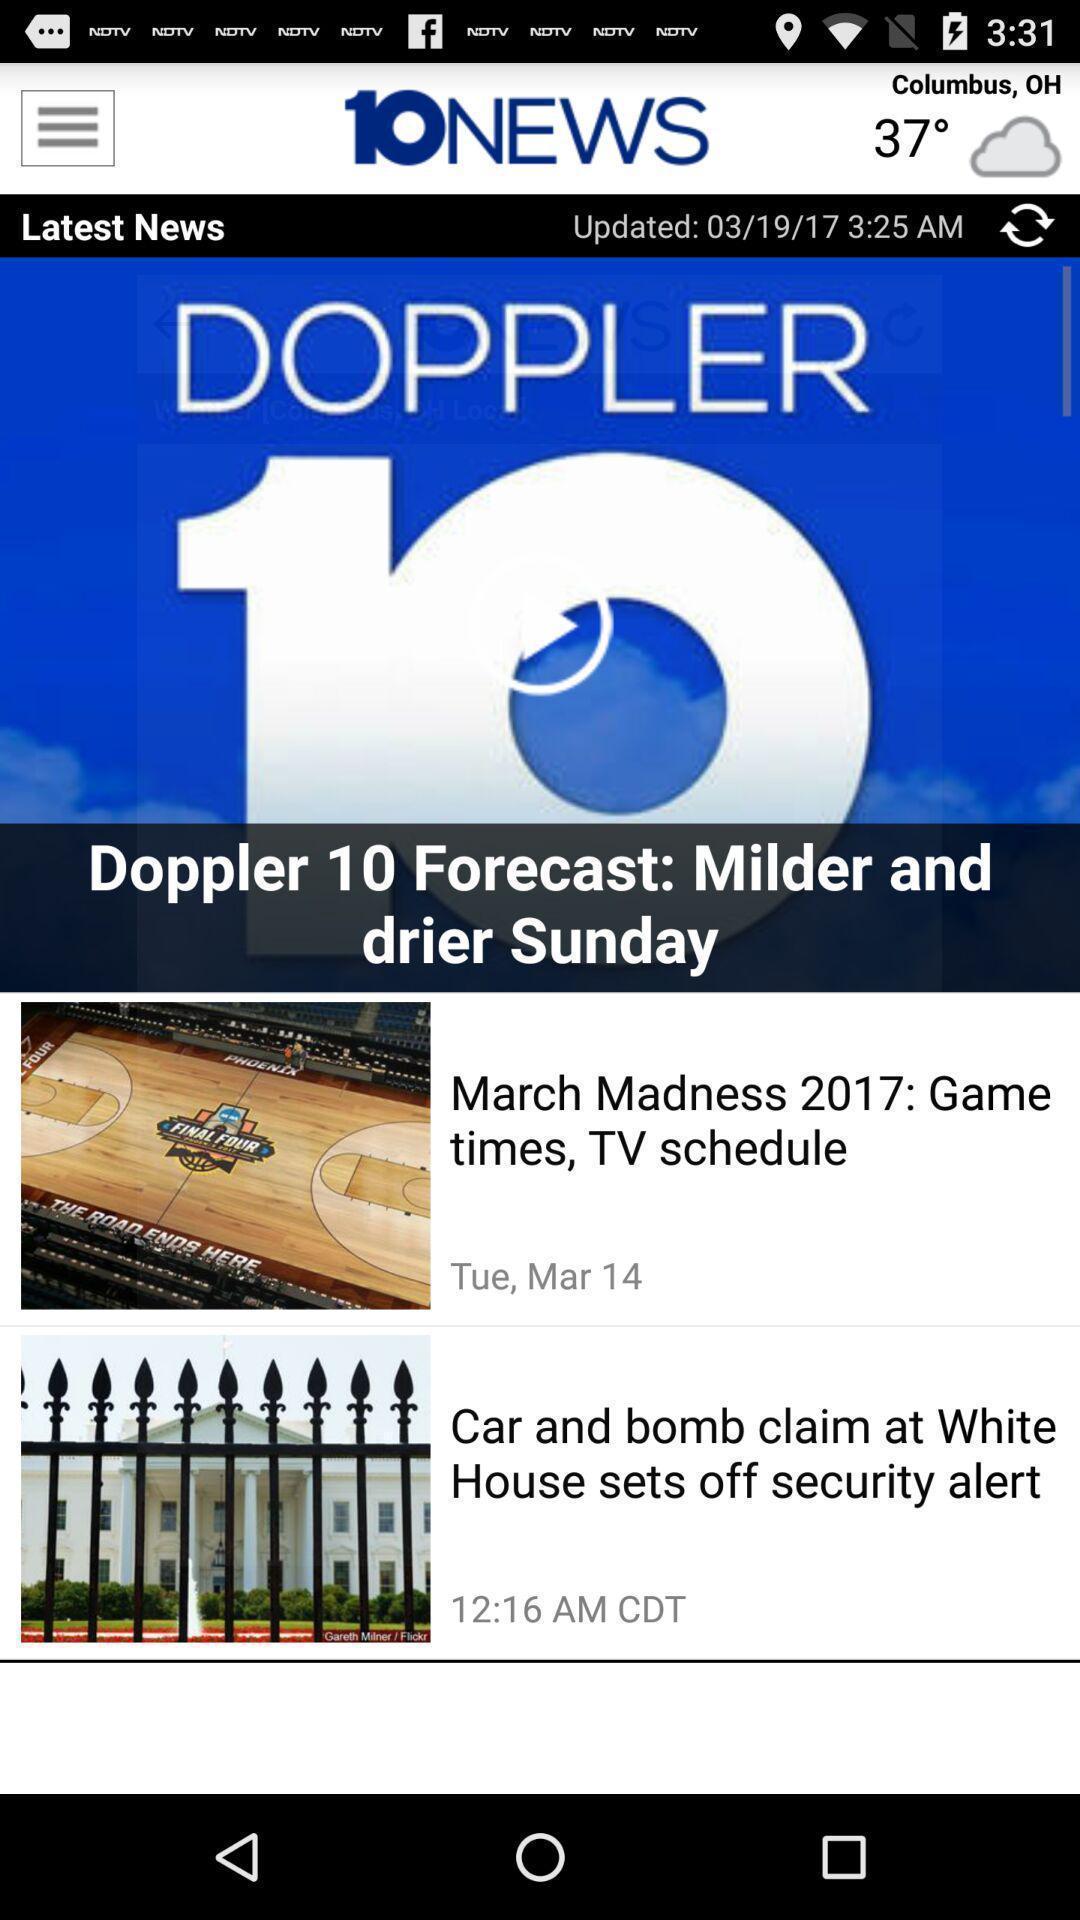Provide a description of this screenshot. Screen showing latest news in an news application. 